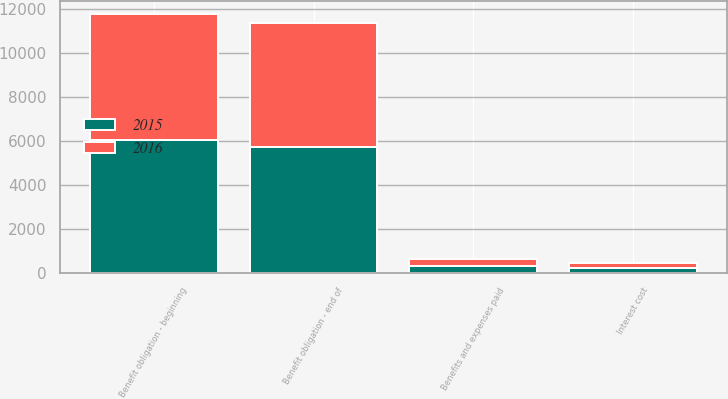Convert chart. <chart><loc_0><loc_0><loc_500><loc_500><stacked_bar_chart><ecel><fcel>Benefit obligation - beginning<fcel>Interest cost<fcel>Benefits and expenses paid<fcel>Benefit obligation - end of<nl><fcel>2016<fcel>5734<fcel>237<fcel>303<fcel>5650<nl><fcel>2015<fcel>6025<fcel>235<fcel>307<fcel>5734<nl></chart> 